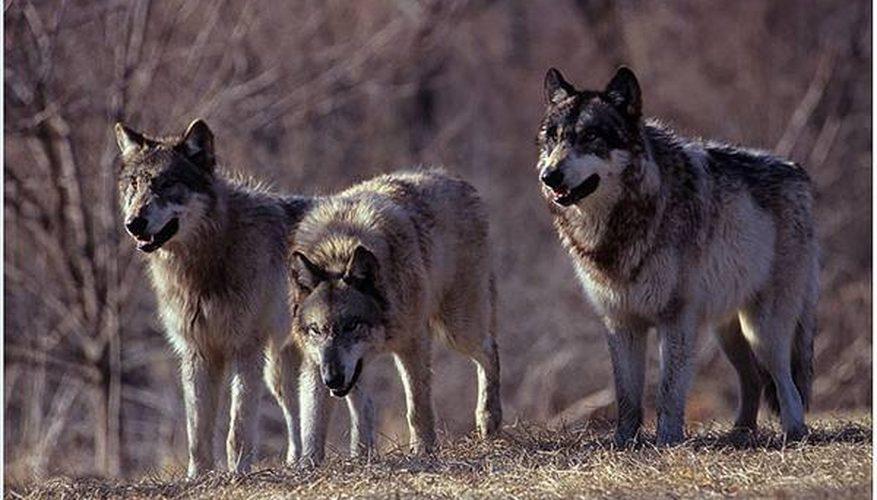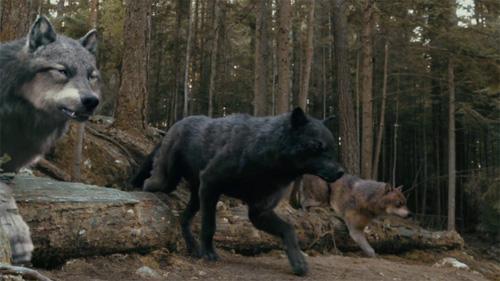The first image is the image on the left, the second image is the image on the right. Assess this claim about the two images: "there are 3 wolves huddled close on snowy ground in both pairs". Correct or not? Answer yes or no. No. The first image is the image on the left, the second image is the image on the right. For the images displayed, is the sentence "One image has three wolves without any snow." factually correct? Answer yes or no. Yes. 